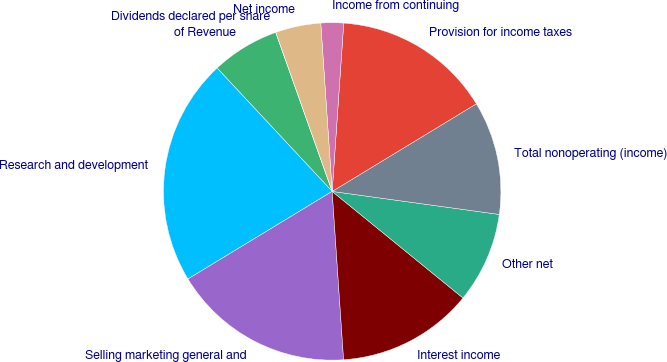Convert chart to OTSL. <chart><loc_0><loc_0><loc_500><loc_500><pie_chart><fcel>of Revenue<fcel>Research and development<fcel>Selling marketing general and<fcel>Interest income<fcel>Other net<fcel>Total nonoperating (income)<fcel>Provision for income taxes<fcel>Income from continuing<fcel>Net income<fcel>Dividends declared per share<nl><fcel>6.52%<fcel>21.74%<fcel>17.39%<fcel>13.04%<fcel>8.7%<fcel>10.87%<fcel>15.22%<fcel>2.17%<fcel>4.35%<fcel>0.0%<nl></chart> 